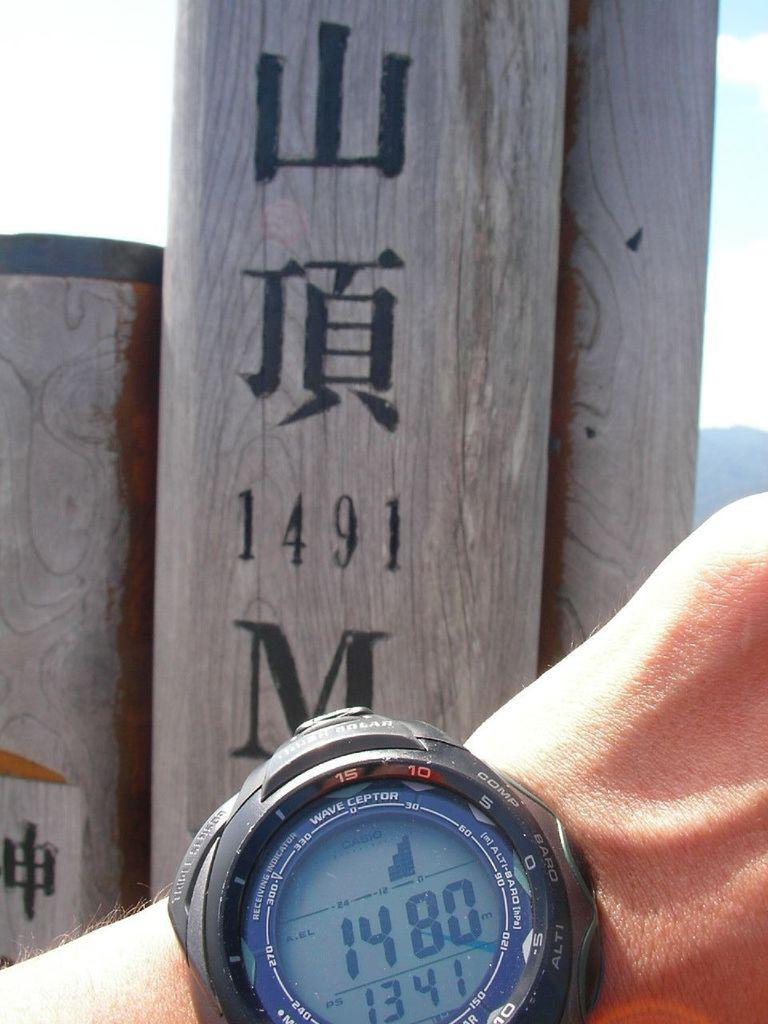<image>
Present a compact description of the photo's key features. Person holding a watch that says 1480 on the face. 